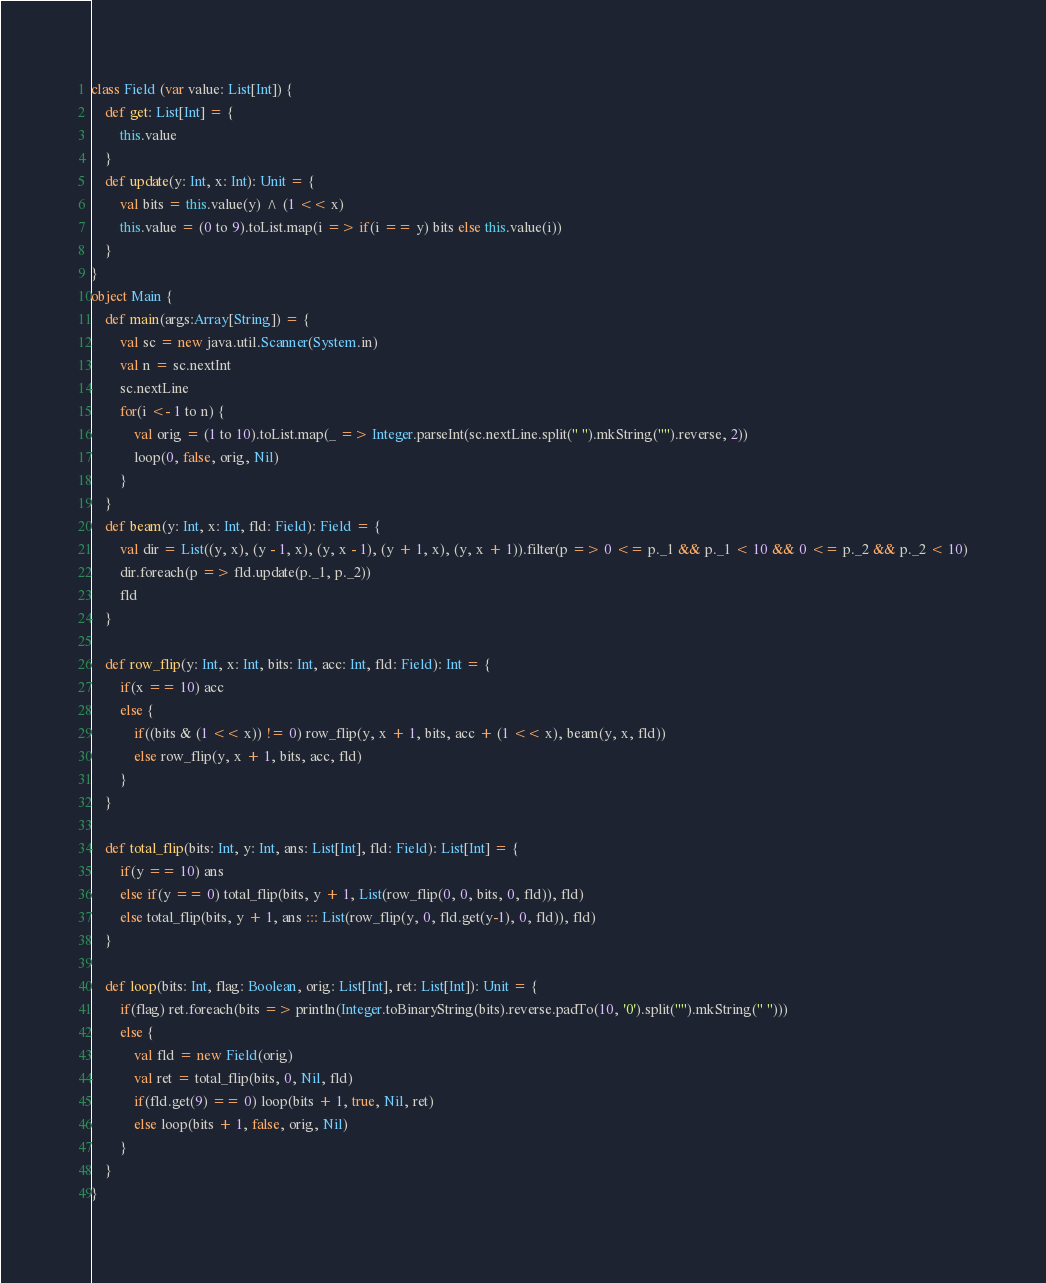<code> <loc_0><loc_0><loc_500><loc_500><_Scala_>class Field (var value: List[Int]) {
    def get: List[Int] = {
        this.value
    }
    def update(y: Int, x: Int): Unit = {
        val bits = this.value(y) ^ (1 << x)
        this.value = (0 to 9).toList.map(i => if(i == y) bits else this.value(i))
    }
}
object Main {
    def main(args:Array[String]) = {
        val sc = new java.util.Scanner(System.in)
        val n = sc.nextInt
        sc.nextLine
        for(i <- 1 to n) {
            val orig = (1 to 10).toList.map(_ => Integer.parseInt(sc.nextLine.split(" ").mkString("").reverse, 2))
            loop(0, false, orig, Nil)
        }
    }
    def beam(y: Int, x: Int, fld: Field): Field = {
        val dir = List((y, x), (y - 1, x), (y, x - 1), (y + 1, x), (y, x + 1)).filter(p => 0 <= p._1 && p._1 < 10 && 0 <= p._2 && p._2 < 10)
        dir.foreach(p => fld.update(p._1, p._2))
        fld
    }

    def row_flip(y: Int, x: Int, bits: Int, acc: Int, fld: Field): Int = {
        if(x == 10) acc
        else {
            if((bits & (1 << x)) != 0) row_flip(y, x + 1, bits, acc + (1 << x), beam(y, x, fld))
            else row_flip(y, x + 1, bits, acc, fld)
        }
    }

    def total_flip(bits: Int, y: Int, ans: List[Int], fld: Field): List[Int] = {
        if(y == 10) ans
        else if(y == 0) total_flip(bits, y + 1, List(row_flip(0, 0, bits, 0, fld)), fld)
        else total_flip(bits, y + 1, ans ::: List(row_flip(y, 0, fld.get(y-1), 0, fld)), fld)
    }

    def loop(bits: Int, flag: Boolean, orig: List[Int], ret: List[Int]): Unit = {
        if(flag) ret.foreach(bits => println(Integer.toBinaryString(bits).reverse.padTo(10, '0').split("").mkString(" ")))
        else {
            val fld = new Field(orig)
            val ret = total_flip(bits, 0, Nil, fld)
            if(fld.get(9) == 0) loop(bits + 1, true, Nil, ret)
            else loop(bits + 1, false, orig, Nil)
        }
    }
}</code> 